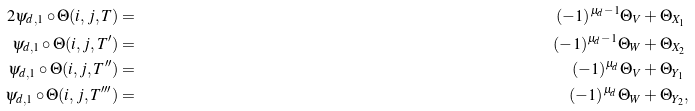<formula> <loc_0><loc_0><loc_500><loc_500>2 \psi _ { d , 1 } \circ \Theta ( i , j , T ) & = & ( { - } 1 ) ^ { \mu _ { d } - 1 } \Theta _ { V } & + \Theta _ { X _ { 1 } } \\ \psi _ { d , 1 } \circ \Theta ( i , j , T ^ { \prime } ) & = \ & ( { - } 1 ) ^ { \mu _ { d } - 1 } \Theta _ { W } & + \Theta _ { X _ { 2 } } \\ \psi _ { d , 1 } \circ \Theta ( i , j , T ^ { \prime \prime } ) & = & ( { - } 1 ) ^ { \mu _ { d } } \Theta _ { V } & + \Theta _ { Y _ { 1 } } \\ \psi _ { d , 1 } \circ \Theta ( i , j , T ^ { \prime \prime \prime } ) & = & ( { - } 1 ) ^ { \mu _ { d } } \Theta _ { W } & + \Theta _ { Y _ { 2 } } ,</formula> 